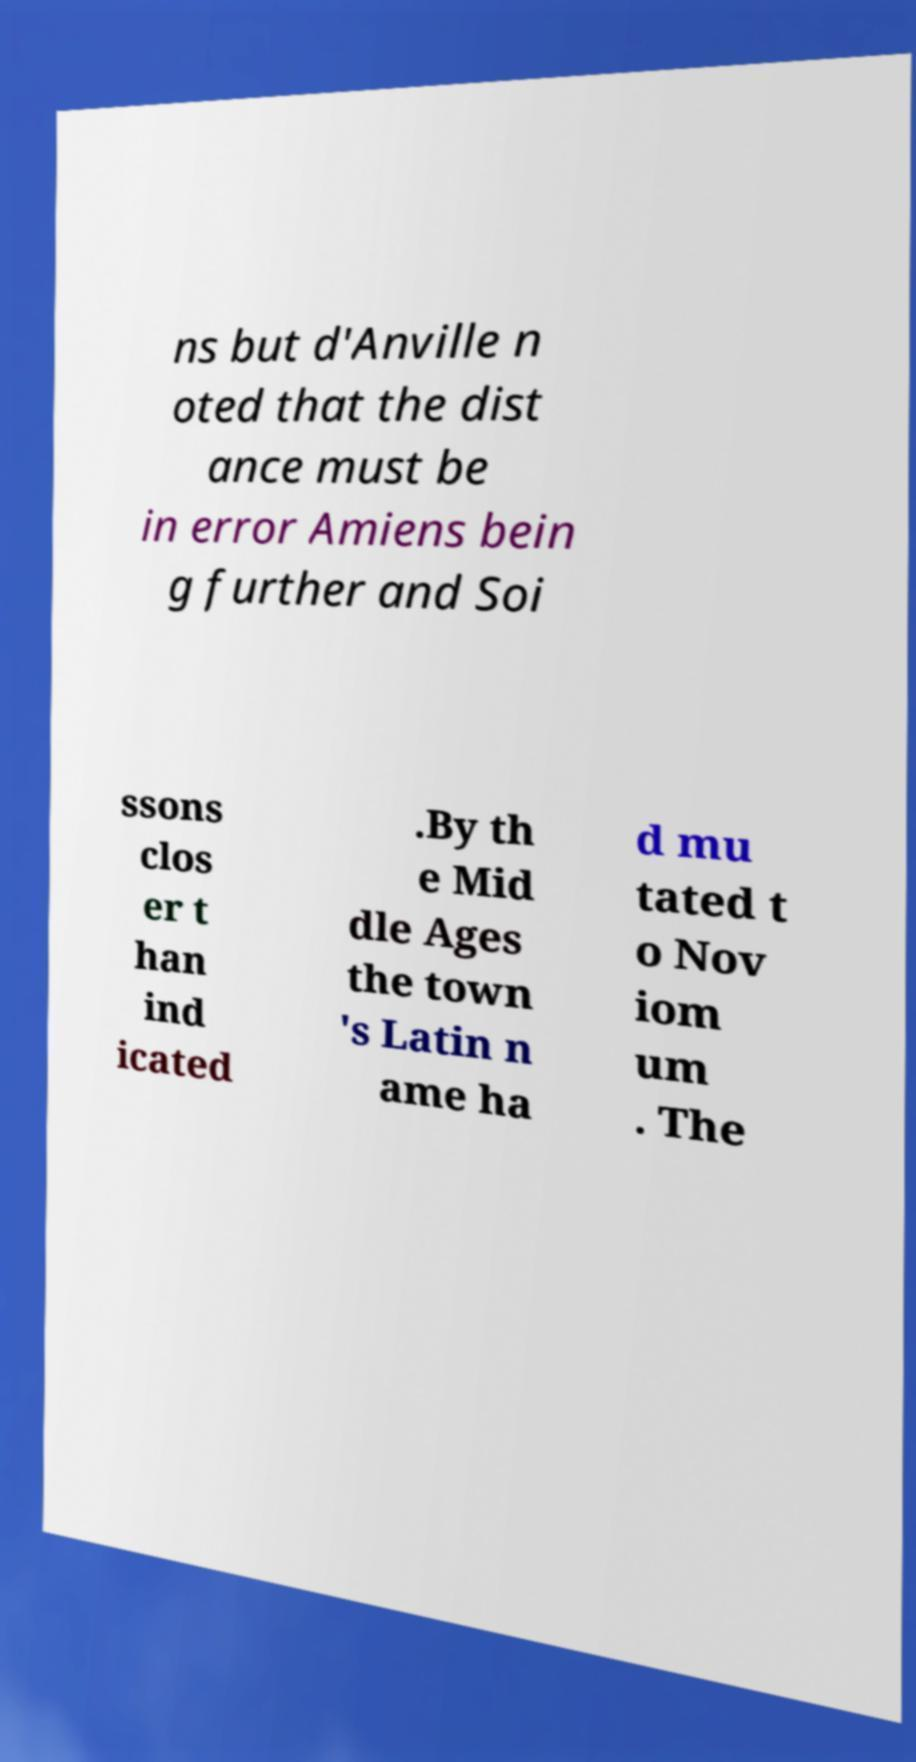For documentation purposes, I need the text within this image transcribed. Could you provide that? ns but d'Anville n oted that the dist ance must be in error Amiens bein g further and Soi ssons clos er t han ind icated .By th e Mid dle Ages the town 's Latin n ame ha d mu tated t o Nov iom um . The 